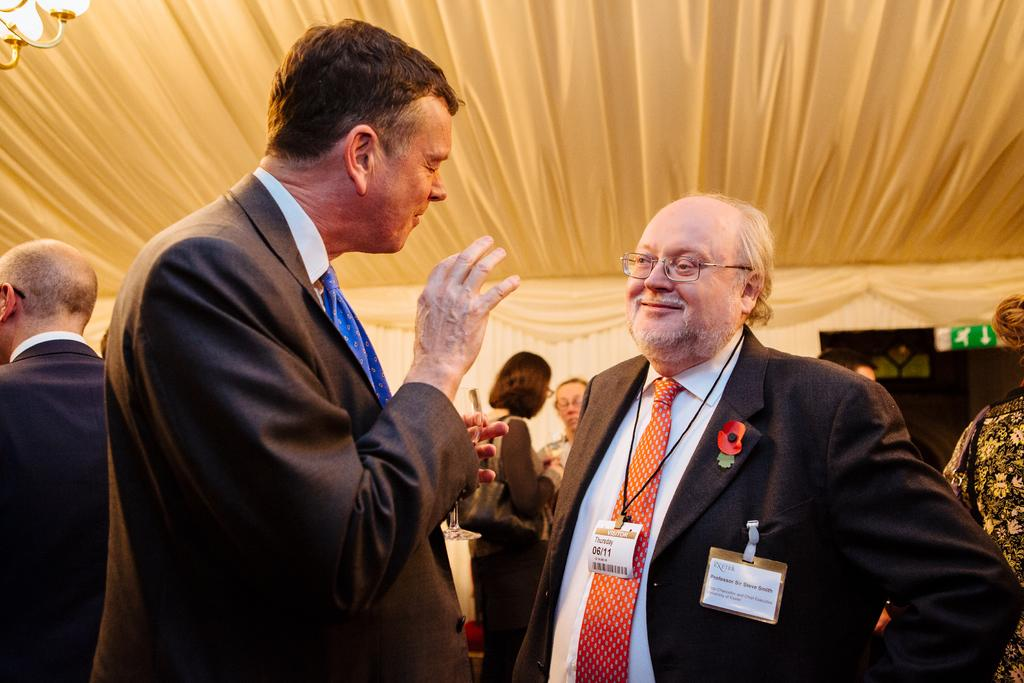How many people are standing in the image? There are two persons standing in the image. What is the man holding in the image? The man is holding a wine glass. Can you describe the other people in the image? There are other people standing in the image. What type of lighting fixture is visible in the image? There is a chandelier visible in the image. What other objects can be seen in the image? There are other objects present in the image. What direction is the wind blowing in the image? There is no indication of wind or its direction in the image. How does the faucet work in the image? There is no faucet present in the image. 